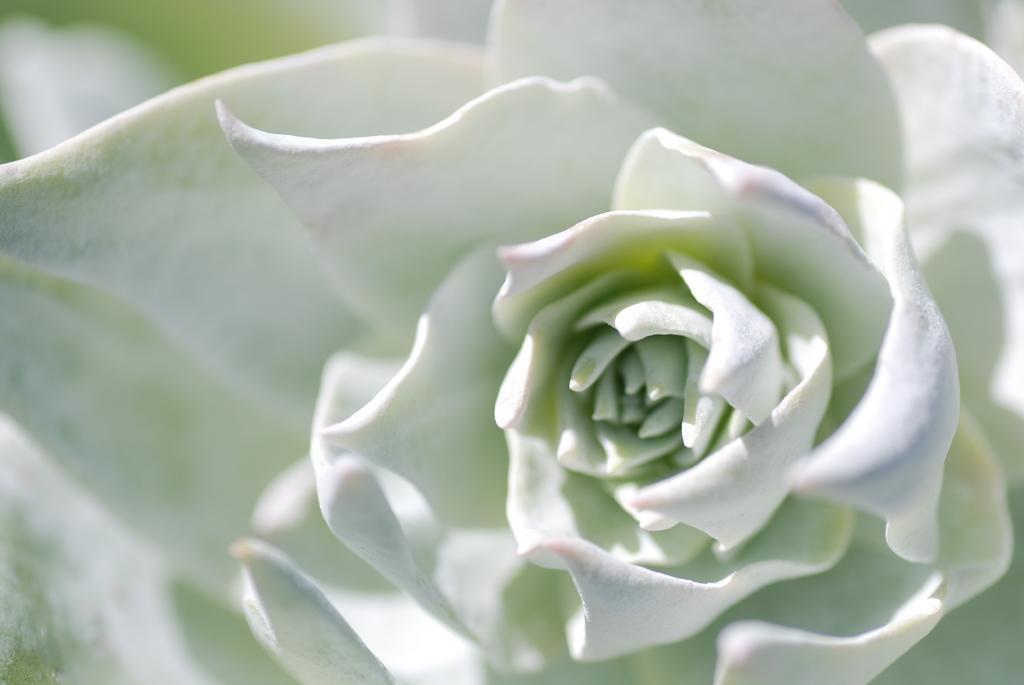Can you describe this image briefly? In this image in the foreground there is one flower, which is white in color. 